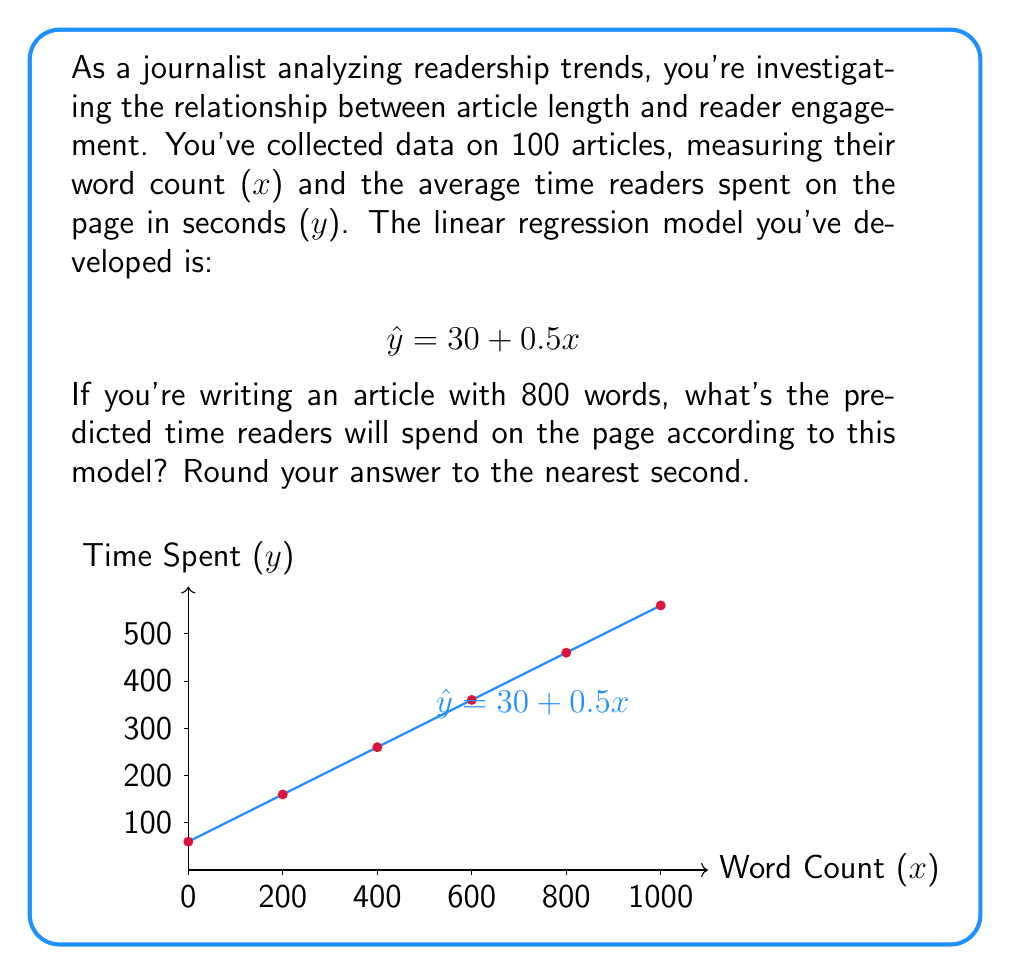Help me with this question. To solve this problem, we'll follow these steps:

1) We have the linear regression model: $\hat{y} = 30 + 0.5x$
   Where $x$ is the word count and $\hat{y}$ is the predicted time spent on the page in seconds.

2) We want to predict the time for an article with 800 words, so we'll substitute $x = 800$ into our model:

   $\hat{y} = 30 + 0.5(800)$

3) Let's calculate:
   $\hat{y} = 30 + 400$
   $\hat{y} = 430$

4) The question asks to round to the nearest second, but 430 is already a whole number, so no rounding is necessary.

Therefore, the model predicts that readers will spend 430 seconds on an 800-word article.
Answer: 430 seconds 